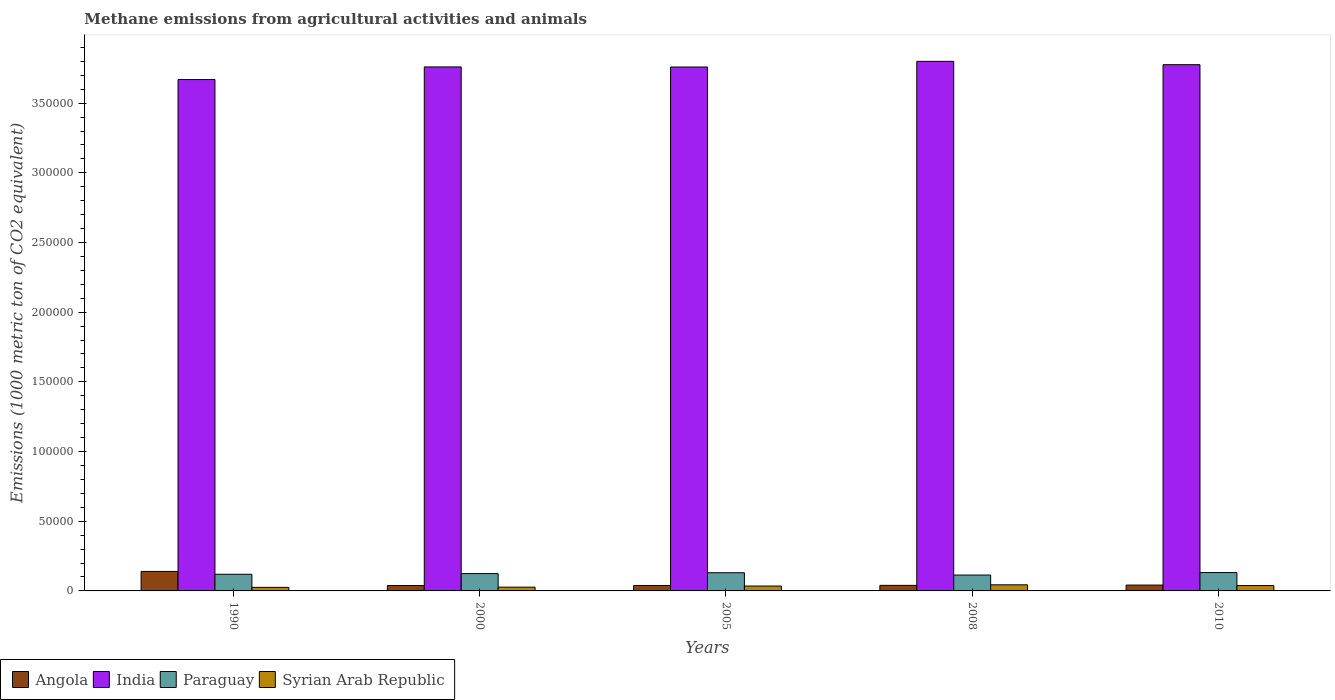How many different coloured bars are there?
Give a very brief answer. 4. How many groups of bars are there?
Your answer should be very brief. 5. Are the number of bars per tick equal to the number of legend labels?
Provide a short and direct response. Yes. Are the number of bars on each tick of the X-axis equal?
Your answer should be very brief. Yes. How many bars are there on the 5th tick from the left?
Provide a short and direct response. 4. In how many cases, is the number of bars for a given year not equal to the number of legend labels?
Your answer should be compact. 0. What is the amount of methane emitted in Angola in 2010?
Offer a terse response. 4188. Across all years, what is the maximum amount of methane emitted in Paraguay?
Your response must be concise. 1.32e+04. Across all years, what is the minimum amount of methane emitted in Angola?
Your answer should be very brief. 3884.4. What is the total amount of methane emitted in Syrian Arab Republic in the graph?
Ensure brevity in your answer.  1.70e+04. What is the difference between the amount of methane emitted in Angola in 2000 and that in 2008?
Provide a succinct answer. -97.6. What is the difference between the amount of methane emitted in Angola in 2008 and the amount of methane emitted in Paraguay in 2010?
Provide a short and direct response. -9187.2. What is the average amount of methane emitted in Paraguay per year?
Your answer should be very brief. 1.24e+04. In the year 1990, what is the difference between the amount of methane emitted in Paraguay and amount of methane emitted in India?
Give a very brief answer. -3.55e+05. In how many years, is the amount of methane emitted in Angola greater than 230000 1000 metric ton?
Keep it short and to the point. 0. What is the ratio of the amount of methane emitted in Paraguay in 2000 to that in 2010?
Provide a succinct answer. 0.94. Is the amount of methane emitted in Syrian Arab Republic in 2000 less than that in 2010?
Your response must be concise. Yes. Is the difference between the amount of methane emitted in Paraguay in 1990 and 2000 greater than the difference between the amount of methane emitted in India in 1990 and 2000?
Make the answer very short. Yes. What is the difference between the highest and the second highest amount of methane emitted in India?
Your answer should be very brief. 2391.5. What is the difference between the highest and the lowest amount of methane emitted in Syrian Arab Republic?
Offer a very short reply. 1825.1. In how many years, is the amount of methane emitted in Syrian Arab Republic greater than the average amount of methane emitted in Syrian Arab Republic taken over all years?
Provide a succinct answer. 3. Is the sum of the amount of methane emitted in India in 2000 and 2010 greater than the maximum amount of methane emitted in Paraguay across all years?
Give a very brief answer. Yes. What does the 1st bar from the left in 2010 represents?
Your answer should be very brief. Angola. What does the 4th bar from the right in 2010 represents?
Your response must be concise. Angola. How many bars are there?
Ensure brevity in your answer.  20. Are all the bars in the graph horizontal?
Your response must be concise. No. What is the difference between two consecutive major ticks on the Y-axis?
Offer a very short reply. 5.00e+04. Are the values on the major ticks of Y-axis written in scientific E-notation?
Make the answer very short. No. Does the graph contain grids?
Your answer should be compact. No. How many legend labels are there?
Your answer should be very brief. 4. How are the legend labels stacked?
Give a very brief answer. Horizontal. What is the title of the graph?
Offer a terse response. Methane emissions from agricultural activities and animals. What is the label or title of the Y-axis?
Your answer should be compact. Emissions (1000 metric ton of CO2 equivalent). What is the Emissions (1000 metric ton of CO2 equivalent) in Angola in 1990?
Provide a short and direct response. 1.40e+04. What is the Emissions (1000 metric ton of CO2 equivalent) in India in 1990?
Your answer should be compact. 3.67e+05. What is the Emissions (1000 metric ton of CO2 equivalent) of Paraguay in 1990?
Make the answer very short. 1.20e+04. What is the Emissions (1000 metric ton of CO2 equivalent) of Syrian Arab Republic in 1990?
Make the answer very short. 2551.7. What is the Emissions (1000 metric ton of CO2 equivalent) in Angola in 2000?
Give a very brief answer. 3884.4. What is the Emissions (1000 metric ton of CO2 equivalent) in India in 2000?
Keep it short and to the point. 3.76e+05. What is the Emissions (1000 metric ton of CO2 equivalent) in Paraguay in 2000?
Provide a succinct answer. 1.24e+04. What is the Emissions (1000 metric ton of CO2 equivalent) of Syrian Arab Republic in 2000?
Your answer should be compact. 2708.8. What is the Emissions (1000 metric ton of CO2 equivalent) in Angola in 2005?
Keep it short and to the point. 3902.3. What is the Emissions (1000 metric ton of CO2 equivalent) in India in 2005?
Keep it short and to the point. 3.76e+05. What is the Emissions (1000 metric ton of CO2 equivalent) of Paraguay in 2005?
Offer a very short reply. 1.30e+04. What is the Emissions (1000 metric ton of CO2 equivalent) in Syrian Arab Republic in 2005?
Keep it short and to the point. 3498.3. What is the Emissions (1000 metric ton of CO2 equivalent) of Angola in 2008?
Make the answer very short. 3982. What is the Emissions (1000 metric ton of CO2 equivalent) in India in 2008?
Make the answer very short. 3.80e+05. What is the Emissions (1000 metric ton of CO2 equivalent) of Paraguay in 2008?
Provide a succinct answer. 1.14e+04. What is the Emissions (1000 metric ton of CO2 equivalent) in Syrian Arab Republic in 2008?
Your answer should be compact. 4376.8. What is the Emissions (1000 metric ton of CO2 equivalent) in Angola in 2010?
Ensure brevity in your answer.  4188. What is the Emissions (1000 metric ton of CO2 equivalent) in India in 2010?
Provide a succinct answer. 3.78e+05. What is the Emissions (1000 metric ton of CO2 equivalent) of Paraguay in 2010?
Your answer should be very brief. 1.32e+04. What is the Emissions (1000 metric ton of CO2 equivalent) in Syrian Arab Republic in 2010?
Give a very brief answer. 3839.8. Across all years, what is the maximum Emissions (1000 metric ton of CO2 equivalent) of Angola?
Provide a short and direct response. 1.40e+04. Across all years, what is the maximum Emissions (1000 metric ton of CO2 equivalent) of India?
Ensure brevity in your answer.  3.80e+05. Across all years, what is the maximum Emissions (1000 metric ton of CO2 equivalent) of Paraguay?
Provide a short and direct response. 1.32e+04. Across all years, what is the maximum Emissions (1000 metric ton of CO2 equivalent) in Syrian Arab Republic?
Make the answer very short. 4376.8. Across all years, what is the minimum Emissions (1000 metric ton of CO2 equivalent) in Angola?
Offer a very short reply. 3884.4. Across all years, what is the minimum Emissions (1000 metric ton of CO2 equivalent) in India?
Your answer should be very brief. 3.67e+05. Across all years, what is the minimum Emissions (1000 metric ton of CO2 equivalent) of Paraguay?
Offer a very short reply. 1.14e+04. Across all years, what is the minimum Emissions (1000 metric ton of CO2 equivalent) in Syrian Arab Republic?
Provide a short and direct response. 2551.7. What is the total Emissions (1000 metric ton of CO2 equivalent) in Angola in the graph?
Your answer should be very brief. 3.00e+04. What is the total Emissions (1000 metric ton of CO2 equivalent) in India in the graph?
Ensure brevity in your answer.  1.88e+06. What is the total Emissions (1000 metric ton of CO2 equivalent) of Paraguay in the graph?
Offer a terse response. 6.20e+04. What is the total Emissions (1000 metric ton of CO2 equivalent) of Syrian Arab Republic in the graph?
Make the answer very short. 1.70e+04. What is the difference between the Emissions (1000 metric ton of CO2 equivalent) of Angola in 1990 and that in 2000?
Make the answer very short. 1.01e+04. What is the difference between the Emissions (1000 metric ton of CO2 equivalent) in India in 1990 and that in 2000?
Offer a very short reply. -9029.4. What is the difference between the Emissions (1000 metric ton of CO2 equivalent) in Paraguay in 1990 and that in 2000?
Provide a succinct answer. -458.8. What is the difference between the Emissions (1000 metric ton of CO2 equivalent) in Syrian Arab Republic in 1990 and that in 2000?
Provide a short and direct response. -157.1. What is the difference between the Emissions (1000 metric ton of CO2 equivalent) in Angola in 1990 and that in 2005?
Your answer should be compact. 1.01e+04. What is the difference between the Emissions (1000 metric ton of CO2 equivalent) in India in 1990 and that in 2005?
Offer a terse response. -8983.7. What is the difference between the Emissions (1000 metric ton of CO2 equivalent) of Paraguay in 1990 and that in 2005?
Your response must be concise. -1085.6. What is the difference between the Emissions (1000 metric ton of CO2 equivalent) in Syrian Arab Republic in 1990 and that in 2005?
Provide a short and direct response. -946.6. What is the difference between the Emissions (1000 metric ton of CO2 equivalent) in Angola in 1990 and that in 2008?
Make the answer very short. 1.00e+04. What is the difference between the Emissions (1000 metric ton of CO2 equivalent) of India in 1990 and that in 2008?
Offer a very short reply. -1.30e+04. What is the difference between the Emissions (1000 metric ton of CO2 equivalent) in Paraguay in 1990 and that in 2008?
Your answer should be compact. 573.8. What is the difference between the Emissions (1000 metric ton of CO2 equivalent) in Syrian Arab Republic in 1990 and that in 2008?
Make the answer very short. -1825.1. What is the difference between the Emissions (1000 metric ton of CO2 equivalent) of Angola in 1990 and that in 2010?
Give a very brief answer. 9807.2. What is the difference between the Emissions (1000 metric ton of CO2 equivalent) in India in 1990 and that in 2010?
Keep it short and to the point. -1.06e+04. What is the difference between the Emissions (1000 metric ton of CO2 equivalent) in Paraguay in 1990 and that in 2010?
Offer a very short reply. -1208.8. What is the difference between the Emissions (1000 metric ton of CO2 equivalent) in Syrian Arab Republic in 1990 and that in 2010?
Your answer should be compact. -1288.1. What is the difference between the Emissions (1000 metric ton of CO2 equivalent) in Angola in 2000 and that in 2005?
Your answer should be very brief. -17.9. What is the difference between the Emissions (1000 metric ton of CO2 equivalent) of India in 2000 and that in 2005?
Provide a succinct answer. 45.7. What is the difference between the Emissions (1000 metric ton of CO2 equivalent) in Paraguay in 2000 and that in 2005?
Your response must be concise. -626.8. What is the difference between the Emissions (1000 metric ton of CO2 equivalent) in Syrian Arab Republic in 2000 and that in 2005?
Your response must be concise. -789.5. What is the difference between the Emissions (1000 metric ton of CO2 equivalent) of Angola in 2000 and that in 2008?
Provide a succinct answer. -97.6. What is the difference between the Emissions (1000 metric ton of CO2 equivalent) in India in 2000 and that in 2008?
Your answer should be compact. -4005.8. What is the difference between the Emissions (1000 metric ton of CO2 equivalent) in Paraguay in 2000 and that in 2008?
Provide a short and direct response. 1032.6. What is the difference between the Emissions (1000 metric ton of CO2 equivalent) in Syrian Arab Republic in 2000 and that in 2008?
Provide a short and direct response. -1668. What is the difference between the Emissions (1000 metric ton of CO2 equivalent) of Angola in 2000 and that in 2010?
Your response must be concise. -303.6. What is the difference between the Emissions (1000 metric ton of CO2 equivalent) in India in 2000 and that in 2010?
Keep it short and to the point. -1614.3. What is the difference between the Emissions (1000 metric ton of CO2 equivalent) of Paraguay in 2000 and that in 2010?
Offer a terse response. -750. What is the difference between the Emissions (1000 metric ton of CO2 equivalent) of Syrian Arab Republic in 2000 and that in 2010?
Give a very brief answer. -1131. What is the difference between the Emissions (1000 metric ton of CO2 equivalent) in Angola in 2005 and that in 2008?
Your response must be concise. -79.7. What is the difference between the Emissions (1000 metric ton of CO2 equivalent) of India in 2005 and that in 2008?
Give a very brief answer. -4051.5. What is the difference between the Emissions (1000 metric ton of CO2 equivalent) of Paraguay in 2005 and that in 2008?
Give a very brief answer. 1659.4. What is the difference between the Emissions (1000 metric ton of CO2 equivalent) of Syrian Arab Republic in 2005 and that in 2008?
Your response must be concise. -878.5. What is the difference between the Emissions (1000 metric ton of CO2 equivalent) in Angola in 2005 and that in 2010?
Offer a terse response. -285.7. What is the difference between the Emissions (1000 metric ton of CO2 equivalent) in India in 2005 and that in 2010?
Your response must be concise. -1660. What is the difference between the Emissions (1000 metric ton of CO2 equivalent) of Paraguay in 2005 and that in 2010?
Provide a succinct answer. -123.2. What is the difference between the Emissions (1000 metric ton of CO2 equivalent) of Syrian Arab Republic in 2005 and that in 2010?
Offer a very short reply. -341.5. What is the difference between the Emissions (1000 metric ton of CO2 equivalent) in Angola in 2008 and that in 2010?
Keep it short and to the point. -206. What is the difference between the Emissions (1000 metric ton of CO2 equivalent) of India in 2008 and that in 2010?
Offer a very short reply. 2391.5. What is the difference between the Emissions (1000 metric ton of CO2 equivalent) of Paraguay in 2008 and that in 2010?
Your answer should be very brief. -1782.6. What is the difference between the Emissions (1000 metric ton of CO2 equivalent) of Syrian Arab Republic in 2008 and that in 2010?
Your answer should be compact. 537. What is the difference between the Emissions (1000 metric ton of CO2 equivalent) of Angola in 1990 and the Emissions (1000 metric ton of CO2 equivalent) of India in 2000?
Your response must be concise. -3.62e+05. What is the difference between the Emissions (1000 metric ton of CO2 equivalent) of Angola in 1990 and the Emissions (1000 metric ton of CO2 equivalent) of Paraguay in 2000?
Offer a terse response. 1576. What is the difference between the Emissions (1000 metric ton of CO2 equivalent) of Angola in 1990 and the Emissions (1000 metric ton of CO2 equivalent) of Syrian Arab Republic in 2000?
Your answer should be very brief. 1.13e+04. What is the difference between the Emissions (1000 metric ton of CO2 equivalent) of India in 1990 and the Emissions (1000 metric ton of CO2 equivalent) of Paraguay in 2000?
Your response must be concise. 3.55e+05. What is the difference between the Emissions (1000 metric ton of CO2 equivalent) of India in 1990 and the Emissions (1000 metric ton of CO2 equivalent) of Syrian Arab Republic in 2000?
Offer a terse response. 3.64e+05. What is the difference between the Emissions (1000 metric ton of CO2 equivalent) in Paraguay in 1990 and the Emissions (1000 metric ton of CO2 equivalent) in Syrian Arab Republic in 2000?
Offer a very short reply. 9251.6. What is the difference between the Emissions (1000 metric ton of CO2 equivalent) in Angola in 1990 and the Emissions (1000 metric ton of CO2 equivalent) in India in 2005?
Your answer should be very brief. -3.62e+05. What is the difference between the Emissions (1000 metric ton of CO2 equivalent) in Angola in 1990 and the Emissions (1000 metric ton of CO2 equivalent) in Paraguay in 2005?
Your answer should be compact. 949.2. What is the difference between the Emissions (1000 metric ton of CO2 equivalent) of Angola in 1990 and the Emissions (1000 metric ton of CO2 equivalent) of Syrian Arab Republic in 2005?
Keep it short and to the point. 1.05e+04. What is the difference between the Emissions (1000 metric ton of CO2 equivalent) of India in 1990 and the Emissions (1000 metric ton of CO2 equivalent) of Paraguay in 2005?
Make the answer very short. 3.54e+05. What is the difference between the Emissions (1000 metric ton of CO2 equivalent) of India in 1990 and the Emissions (1000 metric ton of CO2 equivalent) of Syrian Arab Republic in 2005?
Ensure brevity in your answer.  3.63e+05. What is the difference between the Emissions (1000 metric ton of CO2 equivalent) in Paraguay in 1990 and the Emissions (1000 metric ton of CO2 equivalent) in Syrian Arab Republic in 2005?
Offer a very short reply. 8462.1. What is the difference between the Emissions (1000 metric ton of CO2 equivalent) of Angola in 1990 and the Emissions (1000 metric ton of CO2 equivalent) of India in 2008?
Provide a succinct answer. -3.66e+05. What is the difference between the Emissions (1000 metric ton of CO2 equivalent) in Angola in 1990 and the Emissions (1000 metric ton of CO2 equivalent) in Paraguay in 2008?
Provide a succinct answer. 2608.6. What is the difference between the Emissions (1000 metric ton of CO2 equivalent) of Angola in 1990 and the Emissions (1000 metric ton of CO2 equivalent) of Syrian Arab Republic in 2008?
Provide a short and direct response. 9618.4. What is the difference between the Emissions (1000 metric ton of CO2 equivalent) of India in 1990 and the Emissions (1000 metric ton of CO2 equivalent) of Paraguay in 2008?
Provide a succinct answer. 3.56e+05. What is the difference between the Emissions (1000 metric ton of CO2 equivalent) of India in 1990 and the Emissions (1000 metric ton of CO2 equivalent) of Syrian Arab Republic in 2008?
Ensure brevity in your answer.  3.63e+05. What is the difference between the Emissions (1000 metric ton of CO2 equivalent) in Paraguay in 1990 and the Emissions (1000 metric ton of CO2 equivalent) in Syrian Arab Republic in 2008?
Make the answer very short. 7583.6. What is the difference between the Emissions (1000 metric ton of CO2 equivalent) of Angola in 1990 and the Emissions (1000 metric ton of CO2 equivalent) of India in 2010?
Give a very brief answer. -3.64e+05. What is the difference between the Emissions (1000 metric ton of CO2 equivalent) in Angola in 1990 and the Emissions (1000 metric ton of CO2 equivalent) in Paraguay in 2010?
Offer a very short reply. 826. What is the difference between the Emissions (1000 metric ton of CO2 equivalent) of Angola in 1990 and the Emissions (1000 metric ton of CO2 equivalent) of Syrian Arab Republic in 2010?
Your answer should be compact. 1.02e+04. What is the difference between the Emissions (1000 metric ton of CO2 equivalent) of India in 1990 and the Emissions (1000 metric ton of CO2 equivalent) of Paraguay in 2010?
Provide a succinct answer. 3.54e+05. What is the difference between the Emissions (1000 metric ton of CO2 equivalent) of India in 1990 and the Emissions (1000 metric ton of CO2 equivalent) of Syrian Arab Republic in 2010?
Make the answer very short. 3.63e+05. What is the difference between the Emissions (1000 metric ton of CO2 equivalent) in Paraguay in 1990 and the Emissions (1000 metric ton of CO2 equivalent) in Syrian Arab Republic in 2010?
Your answer should be very brief. 8120.6. What is the difference between the Emissions (1000 metric ton of CO2 equivalent) in Angola in 2000 and the Emissions (1000 metric ton of CO2 equivalent) in India in 2005?
Keep it short and to the point. -3.72e+05. What is the difference between the Emissions (1000 metric ton of CO2 equivalent) of Angola in 2000 and the Emissions (1000 metric ton of CO2 equivalent) of Paraguay in 2005?
Provide a succinct answer. -9161.6. What is the difference between the Emissions (1000 metric ton of CO2 equivalent) of Angola in 2000 and the Emissions (1000 metric ton of CO2 equivalent) of Syrian Arab Republic in 2005?
Keep it short and to the point. 386.1. What is the difference between the Emissions (1000 metric ton of CO2 equivalent) in India in 2000 and the Emissions (1000 metric ton of CO2 equivalent) in Paraguay in 2005?
Provide a short and direct response. 3.63e+05. What is the difference between the Emissions (1000 metric ton of CO2 equivalent) in India in 2000 and the Emissions (1000 metric ton of CO2 equivalent) in Syrian Arab Republic in 2005?
Your answer should be very brief. 3.72e+05. What is the difference between the Emissions (1000 metric ton of CO2 equivalent) of Paraguay in 2000 and the Emissions (1000 metric ton of CO2 equivalent) of Syrian Arab Republic in 2005?
Provide a succinct answer. 8920.9. What is the difference between the Emissions (1000 metric ton of CO2 equivalent) in Angola in 2000 and the Emissions (1000 metric ton of CO2 equivalent) in India in 2008?
Offer a very short reply. -3.76e+05. What is the difference between the Emissions (1000 metric ton of CO2 equivalent) in Angola in 2000 and the Emissions (1000 metric ton of CO2 equivalent) in Paraguay in 2008?
Give a very brief answer. -7502.2. What is the difference between the Emissions (1000 metric ton of CO2 equivalent) of Angola in 2000 and the Emissions (1000 metric ton of CO2 equivalent) of Syrian Arab Republic in 2008?
Provide a succinct answer. -492.4. What is the difference between the Emissions (1000 metric ton of CO2 equivalent) in India in 2000 and the Emissions (1000 metric ton of CO2 equivalent) in Paraguay in 2008?
Ensure brevity in your answer.  3.65e+05. What is the difference between the Emissions (1000 metric ton of CO2 equivalent) in India in 2000 and the Emissions (1000 metric ton of CO2 equivalent) in Syrian Arab Republic in 2008?
Offer a very short reply. 3.72e+05. What is the difference between the Emissions (1000 metric ton of CO2 equivalent) in Paraguay in 2000 and the Emissions (1000 metric ton of CO2 equivalent) in Syrian Arab Republic in 2008?
Make the answer very short. 8042.4. What is the difference between the Emissions (1000 metric ton of CO2 equivalent) in Angola in 2000 and the Emissions (1000 metric ton of CO2 equivalent) in India in 2010?
Provide a succinct answer. -3.74e+05. What is the difference between the Emissions (1000 metric ton of CO2 equivalent) in Angola in 2000 and the Emissions (1000 metric ton of CO2 equivalent) in Paraguay in 2010?
Provide a succinct answer. -9284.8. What is the difference between the Emissions (1000 metric ton of CO2 equivalent) of Angola in 2000 and the Emissions (1000 metric ton of CO2 equivalent) of Syrian Arab Republic in 2010?
Provide a short and direct response. 44.6. What is the difference between the Emissions (1000 metric ton of CO2 equivalent) in India in 2000 and the Emissions (1000 metric ton of CO2 equivalent) in Paraguay in 2010?
Offer a terse response. 3.63e+05. What is the difference between the Emissions (1000 metric ton of CO2 equivalent) in India in 2000 and the Emissions (1000 metric ton of CO2 equivalent) in Syrian Arab Republic in 2010?
Ensure brevity in your answer.  3.72e+05. What is the difference between the Emissions (1000 metric ton of CO2 equivalent) in Paraguay in 2000 and the Emissions (1000 metric ton of CO2 equivalent) in Syrian Arab Republic in 2010?
Your response must be concise. 8579.4. What is the difference between the Emissions (1000 metric ton of CO2 equivalent) in Angola in 2005 and the Emissions (1000 metric ton of CO2 equivalent) in India in 2008?
Make the answer very short. -3.76e+05. What is the difference between the Emissions (1000 metric ton of CO2 equivalent) of Angola in 2005 and the Emissions (1000 metric ton of CO2 equivalent) of Paraguay in 2008?
Provide a short and direct response. -7484.3. What is the difference between the Emissions (1000 metric ton of CO2 equivalent) in Angola in 2005 and the Emissions (1000 metric ton of CO2 equivalent) in Syrian Arab Republic in 2008?
Keep it short and to the point. -474.5. What is the difference between the Emissions (1000 metric ton of CO2 equivalent) of India in 2005 and the Emissions (1000 metric ton of CO2 equivalent) of Paraguay in 2008?
Offer a very short reply. 3.65e+05. What is the difference between the Emissions (1000 metric ton of CO2 equivalent) in India in 2005 and the Emissions (1000 metric ton of CO2 equivalent) in Syrian Arab Republic in 2008?
Provide a succinct answer. 3.72e+05. What is the difference between the Emissions (1000 metric ton of CO2 equivalent) in Paraguay in 2005 and the Emissions (1000 metric ton of CO2 equivalent) in Syrian Arab Republic in 2008?
Offer a very short reply. 8669.2. What is the difference between the Emissions (1000 metric ton of CO2 equivalent) of Angola in 2005 and the Emissions (1000 metric ton of CO2 equivalent) of India in 2010?
Your answer should be very brief. -3.74e+05. What is the difference between the Emissions (1000 metric ton of CO2 equivalent) of Angola in 2005 and the Emissions (1000 metric ton of CO2 equivalent) of Paraguay in 2010?
Offer a terse response. -9266.9. What is the difference between the Emissions (1000 metric ton of CO2 equivalent) in Angola in 2005 and the Emissions (1000 metric ton of CO2 equivalent) in Syrian Arab Republic in 2010?
Offer a very short reply. 62.5. What is the difference between the Emissions (1000 metric ton of CO2 equivalent) in India in 2005 and the Emissions (1000 metric ton of CO2 equivalent) in Paraguay in 2010?
Give a very brief answer. 3.63e+05. What is the difference between the Emissions (1000 metric ton of CO2 equivalent) in India in 2005 and the Emissions (1000 metric ton of CO2 equivalent) in Syrian Arab Republic in 2010?
Provide a short and direct response. 3.72e+05. What is the difference between the Emissions (1000 metric ton of CO2 equivalent) of Paraguay in 2005 and the Emissions (1000 metric ton of CO2 equivalent) of Syrian Arab Republic in 2010?
Your answer should be compact. 9206.2. What is the difference between the Emissions (1000 metric ton of CO2 equivalent) of Angola in 2008 and the Emissions (1000 metric ton of CO2 equivalent) of India in 2010?
Your response must be concise. -3.74e+05. What is the difference between the Emissions (1000 metric ton of CO2 equivalent) of Angola in 2008 and the Emissions (1000 metric ton of CO2 equivalent) of Paraguay in 2010?
Offer a very short reply. -9187.2. What is the difference between the Emissions (1000 metric ton of CO2 equivalent) of Angola in 2008 and the Emissions (1000 metric ton of CO2 equivalent) of Syrian Arab Republic in 2010?
Offer a terse response. 142.2. What is the difference between the Emissions (1000 metric ton of CO2 equivalent) in India in 2008 and the Emissions (1000 metric ton of CO2 equivalent) in Paraguay in 2010?
Provide a succinct answer. 3.67e+05. What is the difference between the Emissions (1000 metric ton of CO2 equivalent) of India in 2008 and the Emissions (1000 metric ton of CO2 equivalent) of Syrian Arab Republic in 2010?
Keep it short and to the point. 3.76e+05. What is the difference between the Emissions (1000 metric ton of CO2 equivalent) in Paraguay in 2008 and the Emissions (1000 metric ton of CO2 equivalent) in Syrian Arab Republic in 2010?
Ensure brevity in your answer.  7546.8. What is the average Emissions (1000 metric ton of CO2 equivalent) in Angola per year?
Provide a succinct answer. 5990.38. What is the average Emissions (1000 metric ton of CO2 equivalent) of India per year?
Offer a terse response. 3.75e+05. What is the average Emissions (1000 metric ton of CO2 equivalent) of Paraguay per year?
Ensure brevity in your answer.  1.24e+04. What is the average Emissions (1000 metric ton of CO2 equivalent) of Syrian Arab Republic per year?
Make the answer very short. 3395.08. In the year 1990, what is the difference between the Emissions (1000 metric ton of CO2 equivalent) in Angola and Emissions (1000 metric ton of CO2 equivalent) in India?
Make the answer very short. -3.53e+05. In the year 1990, what is the difference between the Emissions (1000 metric ton of CO2 equivalent) in Angola and Emissions (1000 metric ton of CO2 equivalent) in Paraguay?
Your response must be concise. 2034.8. In the year 1990, what is the difference between the Emissions (1000 metric ton of CO2 equivalent) in Angola and Emissions (1000 metric ton of CO2 equivalent) in Syrian Arab Republic?
Provide a succinct answer. 1.14e+04. In the year 1990, what is the difference between the Emissions (1000 metric ton of CO2 equivalent) of India and Emissions (1000 metric ton of CO2 equivalent) of Paraguay?
Your response must be concise. 3.55e+05. In the year 1990, what is the difference between the Emissions (1000 metric ton of CO2 equivalent) in India and Emissions (1000 metric ton of CO2 equivalent) in Syrian Arab Republic?
Offer a very short reply. 3.64e+05. In the year 1990, what is the difference between the Emissions (1000 metric ton of CO2 equivalent) in Paraguay and Emissions (1000 metric ton of CO2 equivalent) in Syrian Arab Republic?
Offer a very short reply. 9408.7. In the year 2000, what is the difference between the Emissions (1000 metric ton of CO2 equivalent) in Angola and Emissions (1000 metric ton of CO2 equivalent) in India?
Offer a very short reply. -3.72e+05. In the year 2000, what is the difference between the Emissions (1000 metric ton of CO2 equivalent) of Angola and Emissions (1000 metric ton of CO2 equivalent) of Paraguay?
Offer a terse response. -8534.8. In the year 2000, what is the difference between the Emissions (1000 metric ton of CO2 equivalent) of Angola and Emissions (1000 metric ton of CO2 equivalent) of Syrian Arab Republic?
Your answer should be compact. 1175.6. In the year 2000, what is the difference between the Emissions (1000 metric ton of CO2 equivalent) in India and Emissions (1000 metric ton of CO2 equivalent) in Paraguay?
Ensure brevity in your answer.  3.64e+05. In the year 2000, what is the difference between the Emissions (1000 metric ton of CO2 equivalent) in India and Emissions (1000 metric ton of CO2 equivalent) in Syrian Arab Republic?
Your answer should be compact. 3.73e+05. In the year 2000, what is the difference between the Emissions (1000 metric ton of CO2 equivalent) in Paraguay and Emissions (1000 metric ton of CO2 equivalent) in Syrian Arab Republic?
Keep it short and to the point. 9710.4. In the year 2005, what is the difference between the Emissions (1000 metric ton of CO2 equivalent) of Angola and Emissions (1000 metric ton of CO2 equivalent) of India?
Ensure brevity in your answer.  -3.72e+05. In the year 2005, what is the difference between the Emissions (1000 metric ton of CO2 equivalent) in Angola and Emissions (1000 metric ton of CO2 equivalent) in Paraguay?
Ensure brevity in your answer.  -9143.7. In the year 2005, what is the difference between the Emissions (1000 metric ton of CO2 equivalent) in Angola and Emissions (1000 metric ton of CO2 equivalent) in Syrian Arab Republic?
Keep it short and to the point. 404. In the year 2005, what is the difference between the Emissions (1000 metric ton of CO2 equivalent) of India and Emissions (1000 metric ton of CO2 equivalent) of Paraguay?
Ensure brevity in your answer.  3.63e+05. In the year 2005, what is the difference between the Emissions (1000 metric ton of CO2 equivalent) in India and Emissions (1000 metric ton of CO2 equivalent) in Syrian Arab Republic?
Your answer should be very brief. 3.72e+05. In the year 2005, what is the difference between the Emissions (1000 metric ton of CO2 equivalent) in Paraguay and Emissions (1000 metric ton of CO2 equivalent) in Syrian Arab Republic?
Offer a terse response. 9547.7. In the year 2008, what is the difference between the Emissions (1000 metric ton of CO2 equivalent) of Angola and Emissions (1000 metric ton of CO2 equivalent) of India?
Make the answer very short. -3.76e+05. In the year 2008, what is the difference between the Emissions (1000 metric ton of CO2 equivalent) of Angola and Emissions (1000 metric ton of CO2 equivalent) of Paraguay?
Keep it short and to the point. -7404.6. In the year 2008, what is the difference between the Emissions (1000 metric ton of CO2 equivalent) of Angola and Emissions (1000 metric ton of CO2 equivalent) of Syrian Arab Republic?
Keep it short and to the point. -394.8. In the year 2008, what is the difference between the Emissions (1000 metric ton of CO2 equivalent) in India and Emissions (1000 metric ton of CO2 equivalent) in Paraguay?
Provide a short and direct response. 3.69e+05. In the year 2008, what is the difference between the Emissions (1000 metric ton of CO2 equivalent) in India and Emissions (1000 metric ton of CO2 equivalent) in Syrian Arab Republic?
Your answer should be compact. 3.76e+05. In the year 2008, what is the difference between the Emissions (1000 metric ton of CO2 equivalent) of Paraguay and Emissions (1000 metric ton of CO2 equivalent) of Syrian Arab Republic?
Provide a short and direct response. 7009.8. In the year 2010, what is the difference between the Emissions (1000 metric ton of CO2 equivalent) of Angola and Emissions (1000 metric ton of CO2 equivalent) of India?
Ensure brevity in your answer.  -3.73e+05. In the year 2010, what is the difference between the Emissions (1000 metric ton of CO2 equivalent) in Angola and Emissions (1000 metric ton of CO2 equivalent) in Paraguay?
Offer a very short reply. -8981.2. In the year 2010, what is the difference between the Emissions (1000 metric ton of CO2 equivalent) of Angola and Emissions (1000 metric ton of CO2 equivalent) of Syrian Arab Republic?
Make the answer very short. 348.2. In the year 2010, what is the difference between the Emissions (1000 metric ton of CO2 equivalent) in India and Emissions (1000 metric ton of CO2 equivalent) in Paraguay?
Give a very brief answer. 3.64e+05. In the year 2010, what is the difference between the Emissions (1000 metric ton of CO2 equivalent) of India and Emissions (1000 metric ton of CO2 equivalent) of Syrian Arab Republic?
Your answer should be very brief. 3.74e+05. In the year 2010, what is the difference between the Emissions (1000 metric ton of CO2 equivalent) of Paraguay and Emissions (1000 metric ton of CO2 equivalent) of Syrian Arab Republic?
Your answer should be compact. 9329.4. What is the ratio of the Emissions (1000 metric ton of CO2 equivalent) of Angola in 1990 to that in 2000?
Provide a succinct answer. 3.6. What is the ratio of the Emissions (1000 metric ton of CO2 equivalent) in Paraguay in 1990 to that in 2000?
Offer a very short reply. 0.96. What is the ratio of the Emissions (1000 metric ton of CO2 equivalent) of Syrian Arab Republic in 1990 to that in 2000?
Ensure brevity in your answer.  0.94. What is the ratio of the Emissions (1000 metric ton of CO2 equivalent) in Angola in 1990 to that in 2005?
Your answer should be very brief. 3.59. What is the ratio of the Emissions (1000 metric ton of CO2 equivalent) of India in 1990 to that in 2005?
Your response must be concise. 0.98. What is the ratio of the Emissions (1000 metric ton of CO2 equivalent) in Paraguay in 1990 to that in 2005?
Give a very brief answer. 0.92. What is the ratio of the Emissions (1000 metric ton of CO2 equivalent) of Syrian Arab Republic in 1990 to that in 2005?
Provide a short and direct response. 0.73. What is the ratio of the Emissions (1000 metric ton of CO2 equivalent) in Angola in 1990 to that in 2008?
Provide a succinct answer. 3.51. What is the ratio of the Emissions (1000 metric ton of CO2 equivalent) of India in 1990 to that in 2008?
Provide a succinct answer. 0.97. What is the ratio of the Emissions (1000 metric ton of CO2 equivalent) of Paraguay in 1990 to that in 2008?
Your response must be concise. 1.05. What is the ratio of the Emissions (1000 metric ton of CO2 equivalent) of Syrian Arab Republic in 1990 to that in 2008?
Your response must be concise. 0.58. What is the ratio of the Emissions (1000 metric ton of CO2 equivalent) in Angola in 1990 to that in 2010?
Offer a very short reply. 3.34. What is the ratio of the Emissions (1000 metric ton of CO2 equivalent) of India in 1990 to that in 2010?
Make the answer very short. 0.97. What is the ratio of the Emissions (1000 metric ton of CO2 equivalent) of Paraguay in 1990 to that in 2010?
Your response must be concise. 0.91. What is the ratio of the Emissions (1000 metric ton of CO2 equivalent) in Syrian Arab Republic in 1990 to that in 2010?
Keep it short and to the point. 0.66. What is the ratio of the Emissions (1000 metric ton of CO2 equivalent) of India in 2000 to that in 2005?
Provide a short and direct response. 1. What is the ratio of the Emissions (1000 metric ton of CO2 equivalent) in Paraguay in 2000 to that in 2005?
Provide a succinct answer. 0.95. What is the ratio of the Emissions (1000 metric ton of CO2 equivalent) in Syrian Arab Republic in 2000 to that in 2005?
Your answer should be compact. 0.77. What is the ratio of the Emissions (1000 metric ton of CO2 equivalent) in Angola in 2000 to that in 2008?
Offer a terse response. 0.98. What is the ratio of the Emissions (1000 metric ton of CO2 equivalent) of India in 2000 to that in 2008?
Provide a short and direct response. 0.99. What is the ratio of the Emissions (1000 metric ton of CO2 equivalent) in Paraguay in 2000 to that in 2008?
Give a very brief answer. 1.09. What is the ratio of the Emissions (1000 metric ton of CO2 equivalent) in Syrian Arab Republic in 2000 to that in 2008?
Provide a succinct answer. 0.62. What is the ratio of the Emissions (1000 metric ton of CO2 equivalent) in Angola in 2000 to that in 2010?
Offer a very short reply. 0.93. What is the ratio of the Emissions (1000 metric ton of CO2 equivalent) of Paraguay in 2000 to that in 2010?
Give a very brief answer. 0.94. What is the ratio of the Emissions (1000 metric ton of CO2 equivalent) in Syrian Arab Republic in 2000 to that in 2010?
Your answer should be compact. 0.71. What is the ratio of the Emissions (1000 metric ton of CO2 equivalent) in Angola in 2005 to that in 2008?
Offer a very short reply. 0.98. What is the ratio of the Emissions (1000 metric ton of CO2 equivalent) in India in 2005 to that in 2008?
Provide a succinct answer. 0.99. What is the ratio of the Emissions (1000 metric ton of CO2 equivalent) in Paraguay in 2005 to that in 2008?
Ensure brevity in your answer.  1.15. What is the ratio of the Emissions (1000 metric ton of CO2 equivalent) of Syrian Arab Republic in 2005 to that in 2008?
Provide a short and direct response. 0.8. What is the ratio of the Emissions (1000 metric ton of CO2 equivalent) of Angola in 2005 to that in 2010?
Keep it short and to the point. 0.93. What is the ratio of the Emissions (1000 metric ton of CO2 equivalent) in India in 2005 to that in 2010?
Provide a short and direct response. 1. What is the ratio of the Emissions (1000 metric ton of CO2 equivalent) in Paraguay in 2005 to that in 2010?
Ensure brevity in your answer.  0.99. What is the ratio of the Emissions (1000 metric ton of CO2 equivalent) in Syrian Arab Republic in 2005 to that in 2010?
Provide a succinct answer. 0.91. What is the ratio of the Emissions (1000 metric ton of CO2 equivalent) of Angola in 2008 to that in 2010?
Provide a short and direct response. 0.95. What is the ratio of the Emissions (1000 metric ton of CO2 equivalent) in Paraguay in 2008 to that in 2010?
Make the answer very short. 0.86. What is the ratio of the Emissions (1000 metric ton of CO2 equivalent) in Syrian Arab Republic in 2008 to that in 2010?
Make the answer very short. 1.14. What is the difference between the highest and the second highest Emissions (1000 metric ton of CO2 equivalent) in Angola?
Make the answer very short. 9807.2. What is the difference between the highest and the second highest Emissions (1000 metric ton of CO2 equivalent) in India?
Your response must be concise. 2391.5. What is the difference between the highest and the second highest Emissions (1000 metric ton of CO2 equivalent) of Paraguay?
Make the answer very short. 123.2. What is the difference between the highest and the second highest Emissions (1000 metric ton of CO2 equivalent) of Syrian Arab Republic?
Your response must be concise. 537. What is the difference between the highest and the lowest Emissions (1000 metric ton of CO2 equivalent) of Angola?
Your response must be concise. 1.01e+04. What is the difference between the highest and the lowest Emissions (1000 metric ton of CO2 equivalent) of India?
Your answer should be very brief. 1.30e+04. What is the difference between the highest and the lowest Emissions (1000 metric ton of CO2 equivalent) of Paraguay?
Offer a very short reply. 1782.6. What is the difference between the highest and the lowest Emissions (1000 metric ton of CO2 equivalent) in Syrian Arab Republic?
Your response must be concise. 1825.1. 